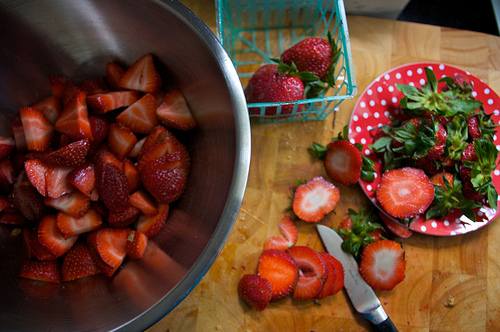<image>
Is the strawberry on the plate? Yes. Looking at the image, I can see the strawberry is positioned on top of the plate, with the plate providing support. Where is the strawberry in relation to the knife? Is it to the right of the knife? Yes. From this viewpoint, the strawberry is positioned to the right side relative to the knife. 